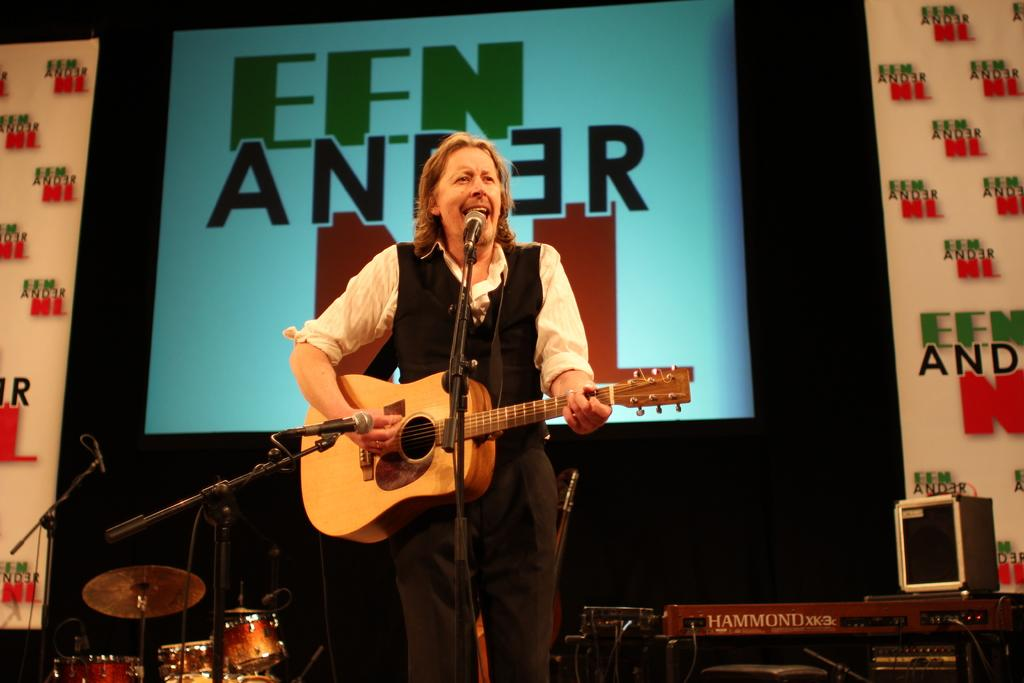What is the man in the image doing? The man is playing a guitar and singing. What instrument is the man using to accompany his singing? The man is playing a guitar. What device is in front of the man? There is a microphone in front of the man. What other musical instruments can be seen in the image? There is a keyboard and drums in the image. What is visible in the background of the image? There is a screen and wallpaper in the background. What type of note is the man holding in the image? There is no note visible in the image; the man is holding a guitar. What type of crate is present in the image? There is no crate present in the image. 